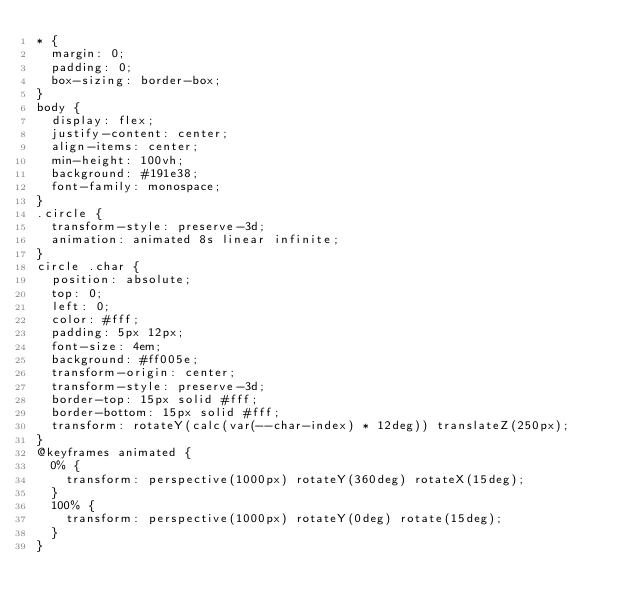Convert code to text. <code><loc_0><loc_0><loc_500><loc_500><_CSS_>* {
  margin: 0;
  padding: 0;
  box-sizing: border-box;
}
body {
  display: flex;
  justify-content: center;
  align-items: center;
  min-height: 100vh;
  background: #191e38;
  font-family: monospace;
}
.circle {
  transform-style: preserve-3d;
  animation: animated 8s linear infinite;
}
circle .char {
  position: absolute;
  top: 0;
  left: 0;
  color: #fff;
  padding: 5px 12px;
  font-size: 4em;
  background: #ff005e;
  transform-origin: center;
  transform-style: preserve-3d;
  border-top: 15px solid #fff;
  border-bottom: 15px solid #fff;
  transform: rotateY(calc(var(--char-index) * 12deg)) translateZ(250px);
}
@keyframes animated {
  0% {
    transform: perspective(1000px) rotateY(360deg) rotateX(15deg);
  }
  100% {
    transform: perspective(1000px) rotateY(0deg) rotate(15deg);
  }
}
</code> 